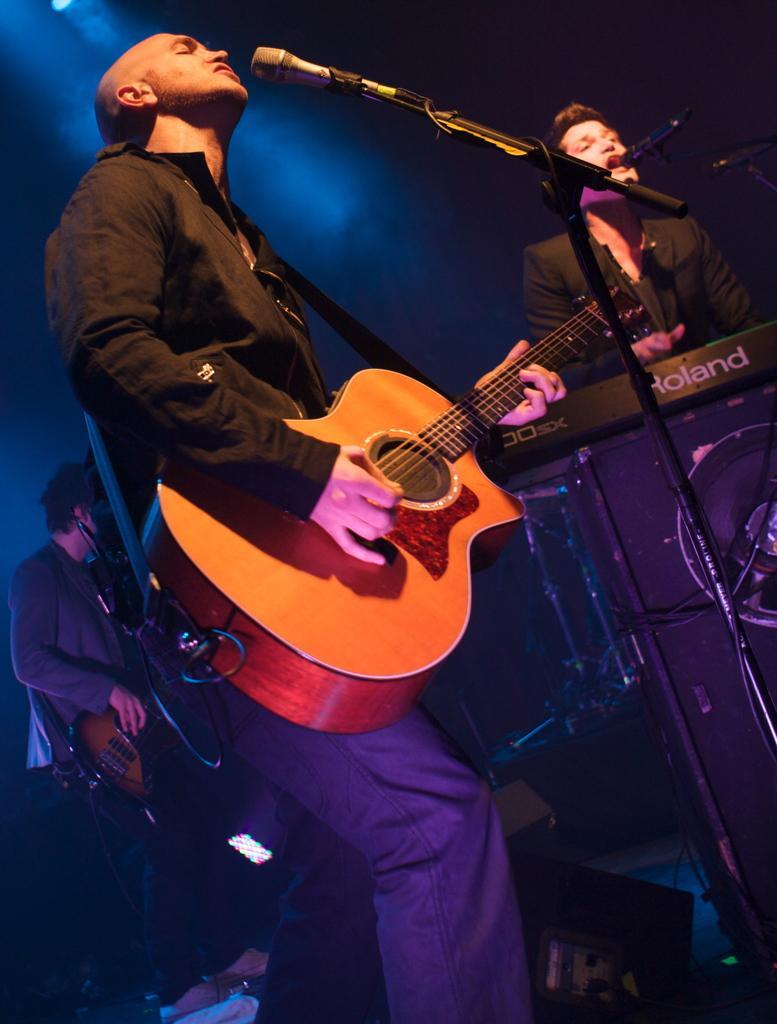In one or two sentences, can you explain what this image depicts? In this image we can see a man holding a guitar in his hands and playing it. On the right side of the image we can see a man playing the piano and singing through mic. 